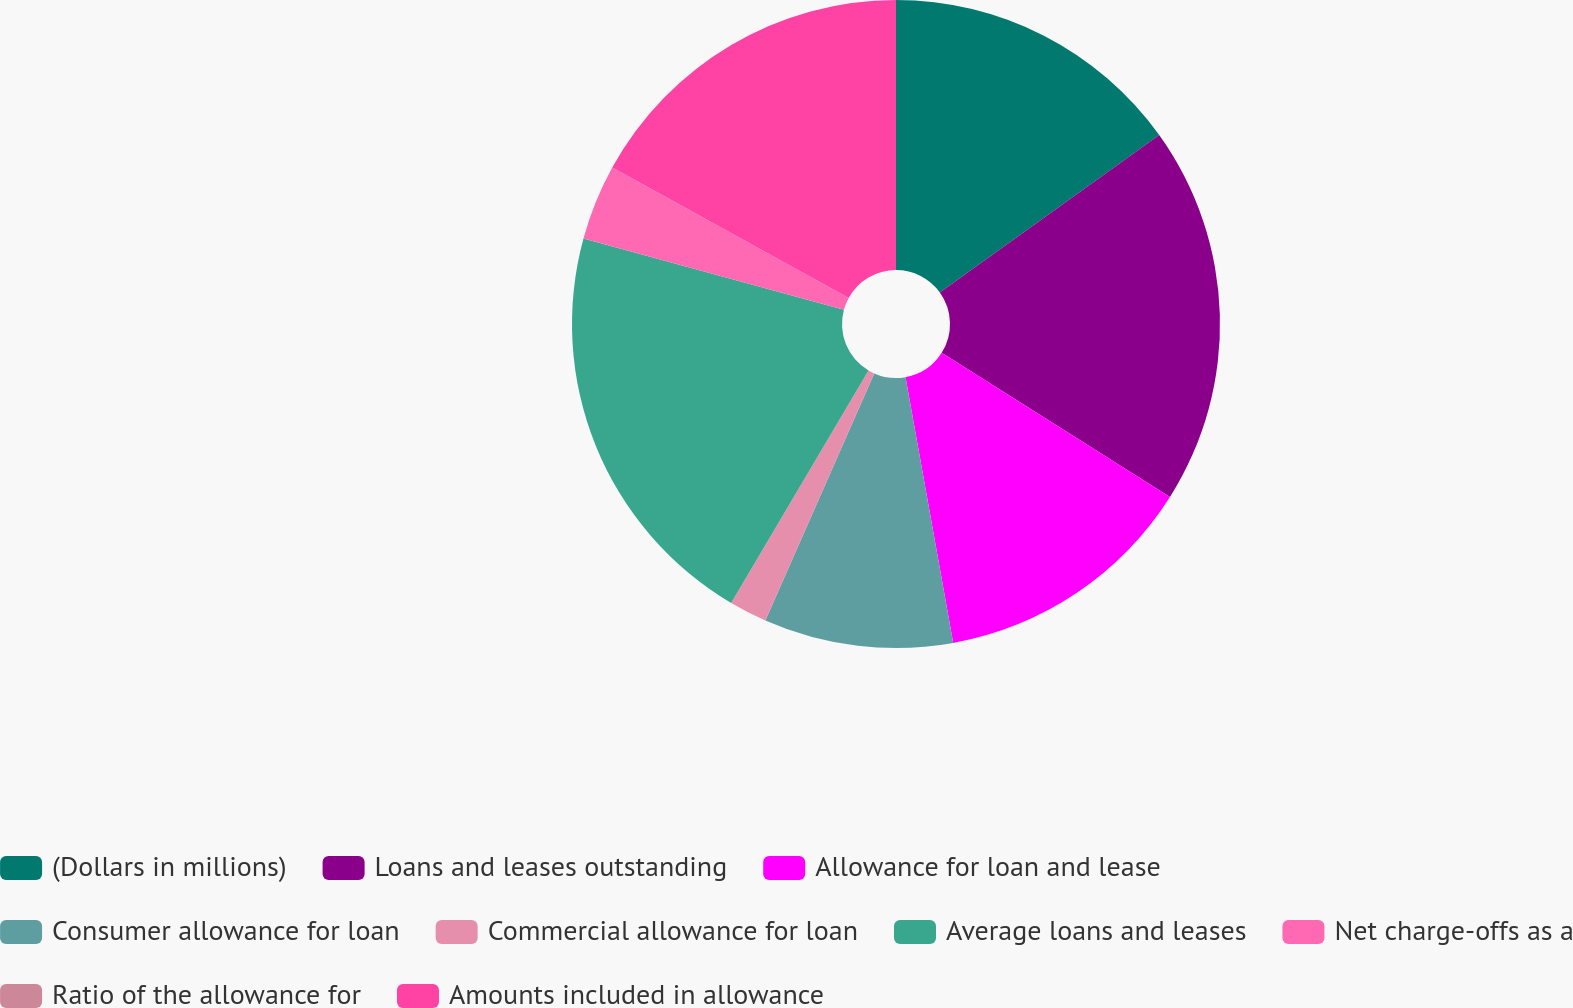<chart> <loc_0><loc_0><loc_500><loc_500><pie_chart><fcel>(Dollars in millions)<fcel>Loans and leases outstanding<fcel>Allowance for loan and lease<fcel>Consumer allowance for loan<fcel>Commercial allowance for loan<fcel>Average loans and leases<fcel>Net charge-offs as a<fcel>Ratio of the allowance for<fcel>Amounts included in allowance<nl><fcel>15.09%<fcel>18.87%<fcel>13.21%<fcel>9.43%<fcel>1.89%<fcel>20.75%<fcel>3.77%<fcel>0.0%<fcel>16.98%<nl></chart> 